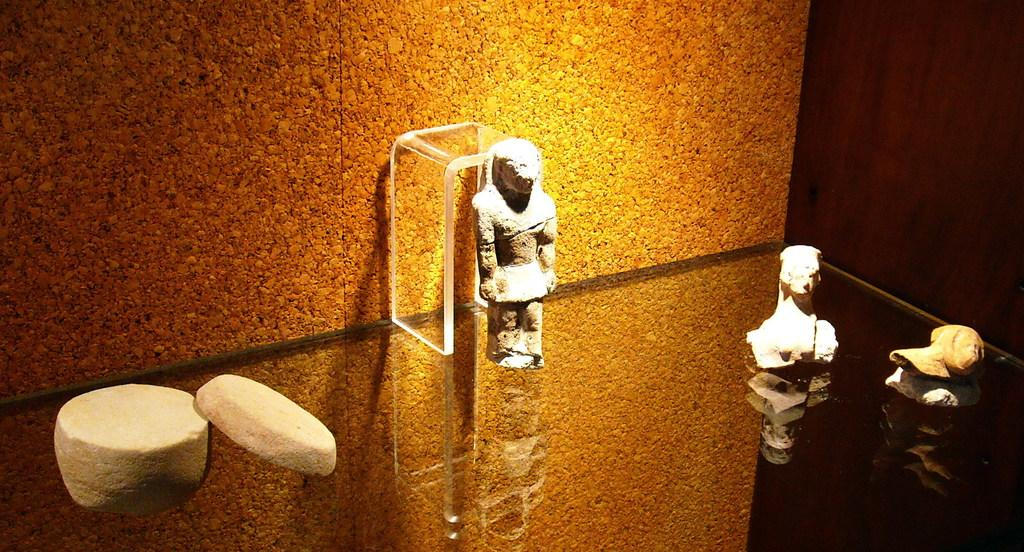What type of structure can be seen in the image? There is a wall in the image. What piece of furniture is present in the image? There is a table in the image. What type of decorative objects are in the image? There are statues in the image. What word is written on the table in the image? There is no word written on the table in the image. What type of calculator can be seen on the wall in the image? There is no calculator present in the image. 